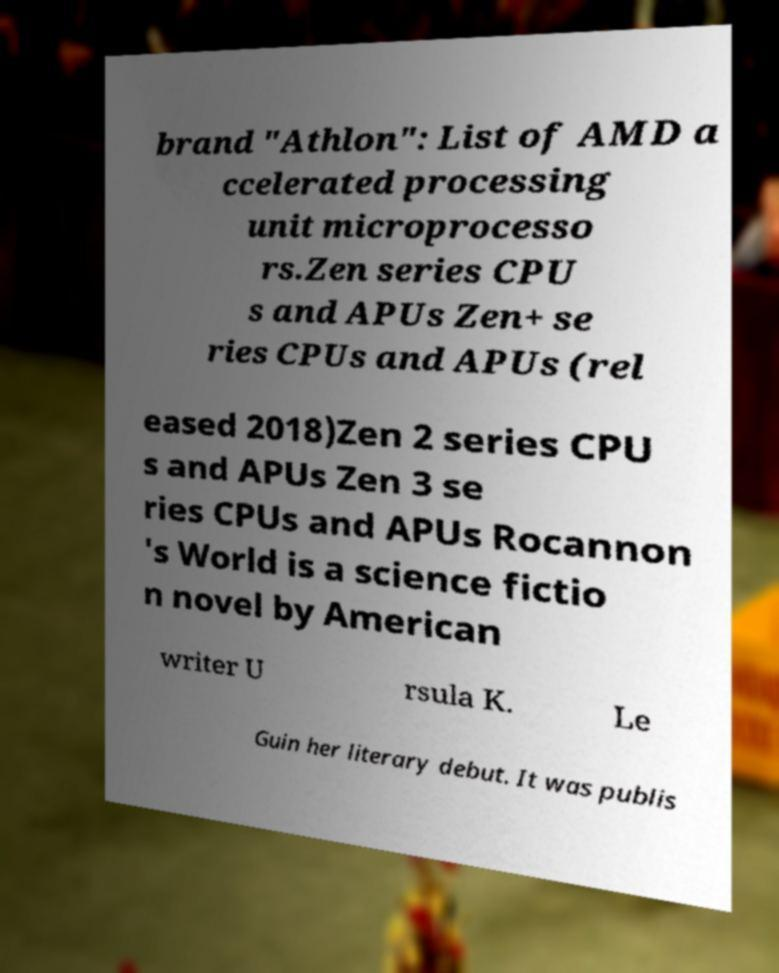What messages or text are displayed in this image? I need them in a readable, typed format. brand "Athlon": List of AMD a ccelerated processing unit microprocesso rs.Zen series CPU s and APUs Zen+ se ries CPUs and APUs (rel eased 2018)Zen 2 series CPU s and APUs Zen 3 se ries CPUs and APUs Rocannon 's World is a science fictio n novel by American writer U rsula K. Le Guin her literary debut. It was publis 